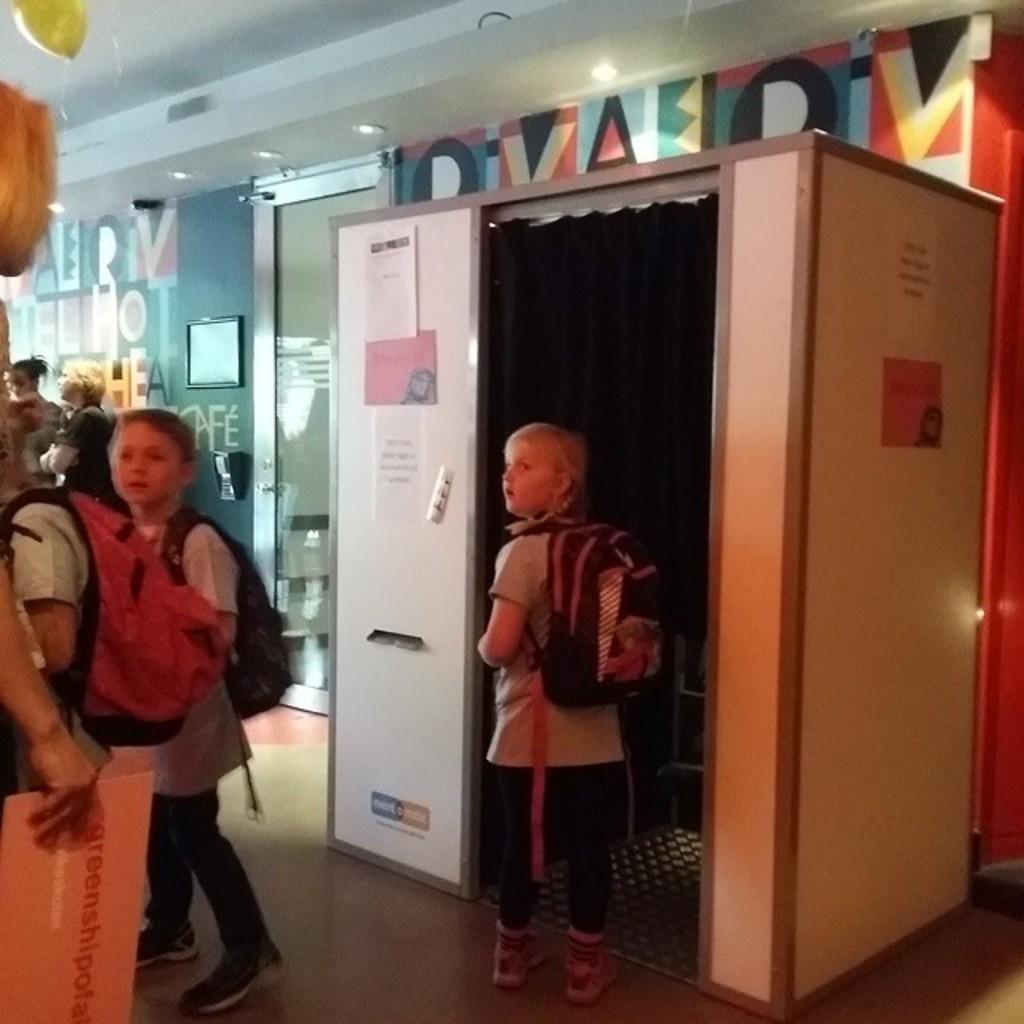Please provide a concise description of this image. Here we can see children and cabin. On this cabin there are posters. This is curtain. These children wore bags. This person is holding a card. Background there is a colorful wall. Picture and device is on the wall. This is a glass door. Lights are attached to the ceiling.  